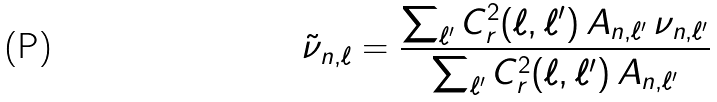Convert formula to latex. <formula><loc_0><loc_0><loc_500><loc_500>\tilde { \nu } _ { n , \ell } = \frac { \sum _ { \ell ^ { \prime } } C _ { r } ^ { 2 } ( \ell , \ell ^ { \prime } ) \, A _ { n , \ell ^ { \prime } } \, \nu _ { n , \ell ^ { \prime } } } { \sum _ { \ell ^ { \prime } } C _ { r } ^ { 2 } ( \ell , \ell ^ { \prime } ) \, A _ { n , \ell ^ { \prime } } }</formula> 